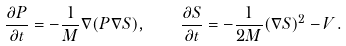<formula> <loc_0><loc_0><loc_500><loc_500>\frac { \partial P } { \partial t } = - \frac { 1 } { M } \nabla ( P \nabla S ) , \quad \frac { \partial S } { \partial t } = - \frac { 1 } { 2 M } ( \nabla S ) ^ { 2 } - V .</formula> 